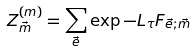<formula> <loc_0><loc_0><loc_500><loc_500>Z ^ { ( m ) } _ { \vec { m } } = \sum _ { \vec { e } } \exp { - L _ { \tau } F _ { \vec { e } ; \vec { m } } }</formula> 